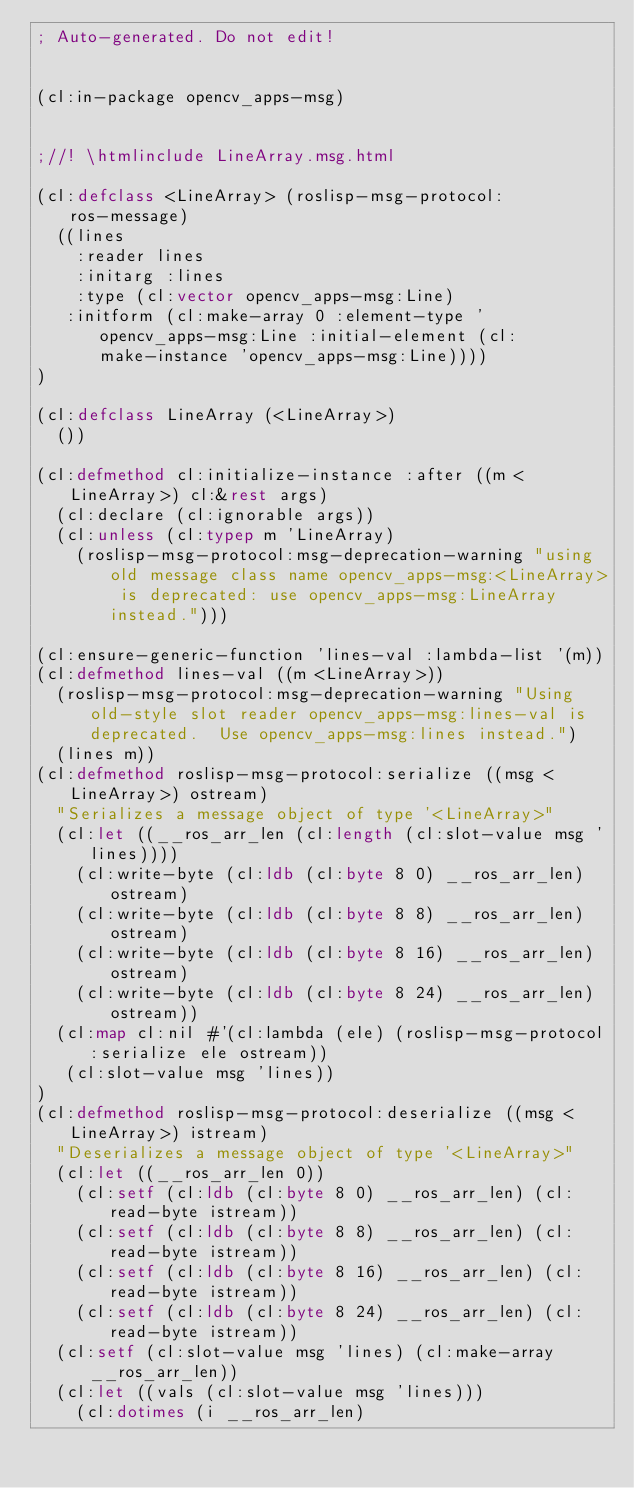Convert code to text. <code><loc_0><loc_0><loc_500><loc_500><_Lisp_>; Auto-generated. Do not edit!


(cl:in-package opencv_apps-msg)


;//! \htmlinclude LineArray.msg.html

(cl:defclass <LineArray> (roslisp-msg-protocol:ros-message)
  ((lines
    :reader lines
    :initarg :lines
    :type (cl:vector opencv_apps-msg:Line)
   :initform (cl:make-array 0 :element-type 'opencv_apps-msg:Line :initial-element (cl:make-instance 'opencv_apps-msg:Line))))
)

(cl:defclass LineArray (<LineArray>)
  ())

(cl:defmethod cl:initialize-instance :after ((m <LineArray>) cl:&rest args)
  (cl:declare (cl:ignorable args))
  (cl:unless (cl:typep m 'LineArray)
    (roslisp-msg-protocol:msg-deprecation-warning "using old message class name opencv_apps-msg:<LineArray> is deprecated: use opencv_apps-msg:LineArray instead.")))

(cl:ensure-generic-function 'lines-val :lambda-list '(m))
(cl:defmethod lines-val ((m <LineArray>))
  (roslisp-msg-protocol:msg-deprecation-warning "Using old-style slot reader opencv_apps-msg:lines-val is deprecated.  Use opencv_apps-msg:lines instead.")
  (lines m))
(cl:defmethod roslisp-msg-protocol:serialize ((msg <LineArray>) ostream)
  "Serializes a message object of type '<LineArray>"
  (cl:let ((__ros_arr_len (cl:length (cl:slot-value msg 'lines))))
    (cl:write-byte (cl:ldb (cl:byte 8 0) __ros_arr_len) ostream)
    (cl:write-byte (cl:ldb (cl:byte 8 8) __ros_arr_len) ostream)
    (cl:write-byte (cl:ldb (cl:byte 8 16) __ros_arr_len) ostream)
    (cl:write-byte (cl:ldb (cl:byte 8 24) __ros_arr_len) ostream))
  (cl:map cl:nil #'(cl:lambda (ele) (roslisp-msg-protocol:serialize ele ostream))
   (cl:slot-value msg 'lines))
)
(cl:defmethod roslisp-msg-protocol:deserialize ((msg <LineArray>) istream)
  "Deserializes a message object of type '<LineArray>"
  (cl:let ((__ros_arr_len 0))
    (cl:setf (cl:ldb (cl:byte 8 0) __ros_arr_len) (cl:read-byte istream))
    (cl:setf (cl:ldb (cl:byte 8 8) __ros_arr_len) (cl:read-byte istream))
    (cl:setf (cl:ldb (cl:byte 8 16) __ros_arr_len) (cl:read-byte istream))
    (cl:setf (cl:ldb (cl:byte 8 24) __ros_arr_len) (cl:read-byte istream))
  (cl:setf (cl:slot-value msg 'lines) (cl:make-array __ros_arr_len))
  (cl:let ((vals (cl:slot-value msg 'lines)))
    (cl:dotimes (i __ros_arr_len)</code> 